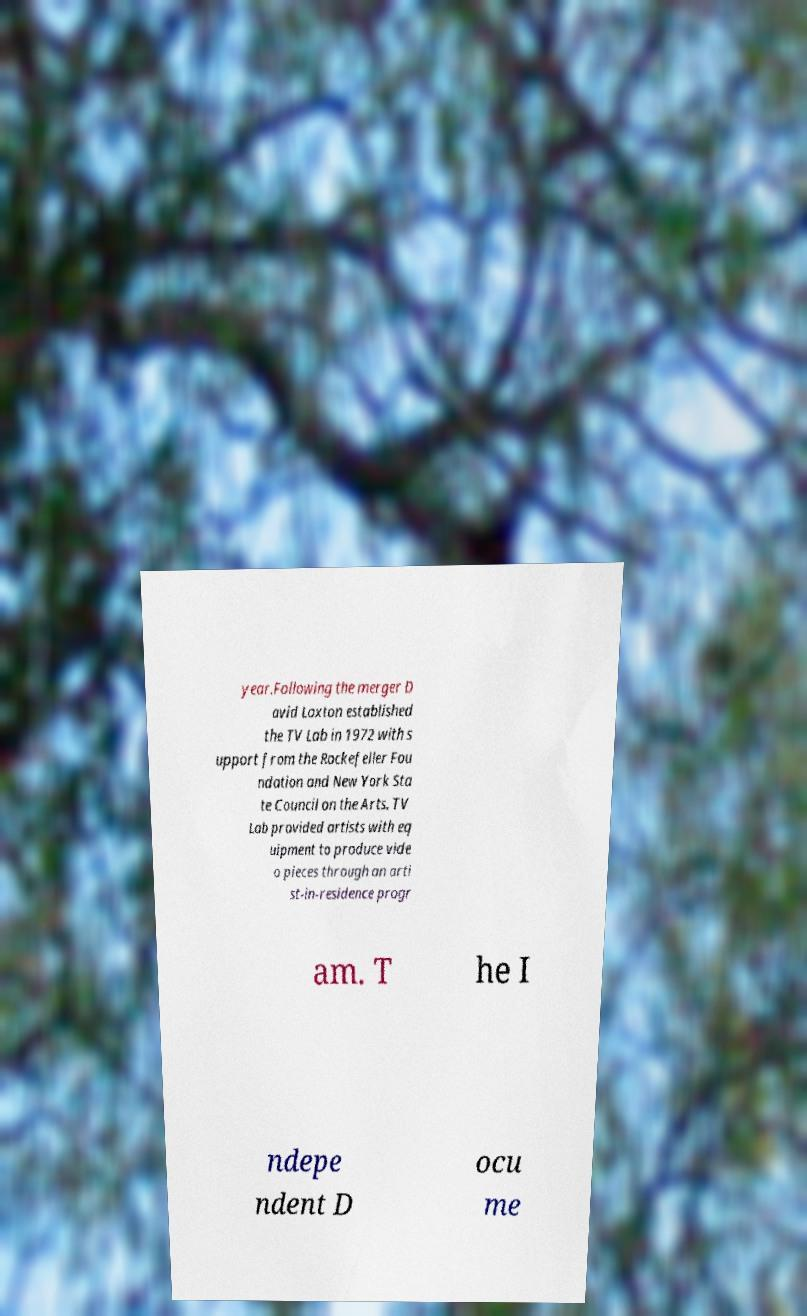Could you extract and type out the text from this image? year.Following the merger D avid Loxton established the TV Lab in 1972 with s upport from the Rockefeller Fou ndation and New York Sta te Council on the Arts. TV Lab provided artists with eq uipment to produce vide o pieces through an arti st-in-residence progr am. T he I ndepe ndent D ocu me 